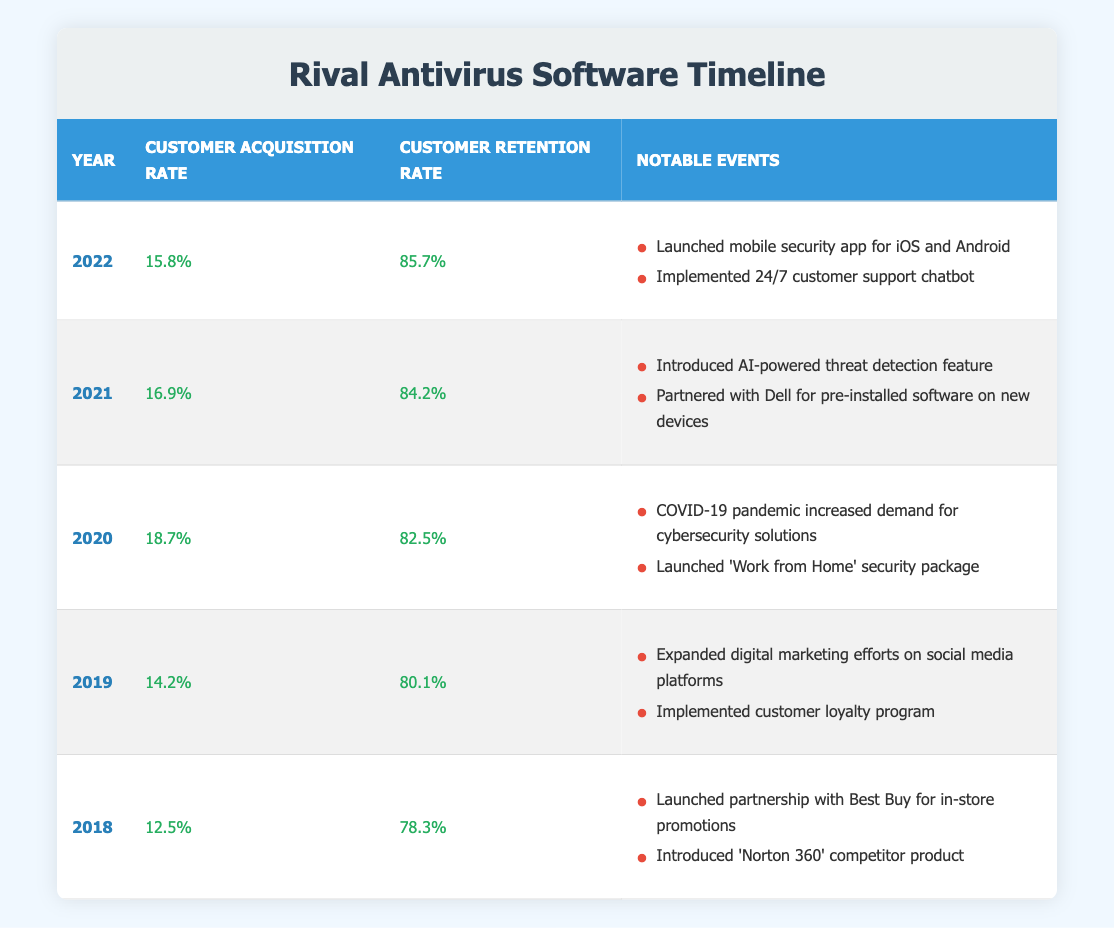What was the customer acquisition rate in 2020? Referring to the table, in the year 2020, the customer acquisition rate is listed as 18.7%.
Answer: 18.7% In which year was the customer retention rate the highest? Looking at the retention rates in the table, the highest value is 85.7%, which occurred in the year 2022.
Answer: 2022 What is the average customer acquisition rate over the five years? The acquisition rates are 12.5%, 14.2%, 18.7%, 16.9%, and 15.8%. Adding them up gives 77.1%. Dividing by the 5 years results in an average of 15.42%.
Answer: 15.42% Did the customer acquisition rate decrease from 2020 to 2021? Comparing the acquisition rates, 2020 has 18.7% and 2021 has 16.9%. Since 16.9% is less than 18.7%, we can conclude that there was a decrease.
Answer: Yes Which year had notable events related to the COVID-19 pandemic? The data indicates that in the year 2020, the notable events included "COVID-19 pandemic increased demand for cybersecurity solutions," confirming that it's the relevant year.
Answer: 2020 What was the difference in customer retention rate between 2018 and 2022? The retention rates are 78.3% in 2018 and 85.7% in 2022. Subtracting gives 85.7% - 78.3% = 7.4%.
Answer: 7.4% How many notable events were associated with the year 2019? In 2019, there are two entries: "Expanded digital marketing efforts on social media platforms" and "Implemented customer loyalty program," indicating a total of two notable events.
Answer: 2 Was there an introduction of a mobile security app in 2021? The table states that one of the notable events in 2021 is "Introduced AI-powered threat detection feature," which does not mention a mobile security app. Thus, the answer is no.
Answer: No What trends can be seen in customer retention rates from 2018 to 2022? By analyzing the retention rates from 78.3% in 2018, increasing each following year to 85.7% in 2022, it indicates a consistent upward trend in retention during this period.
Answer: Upward trend 